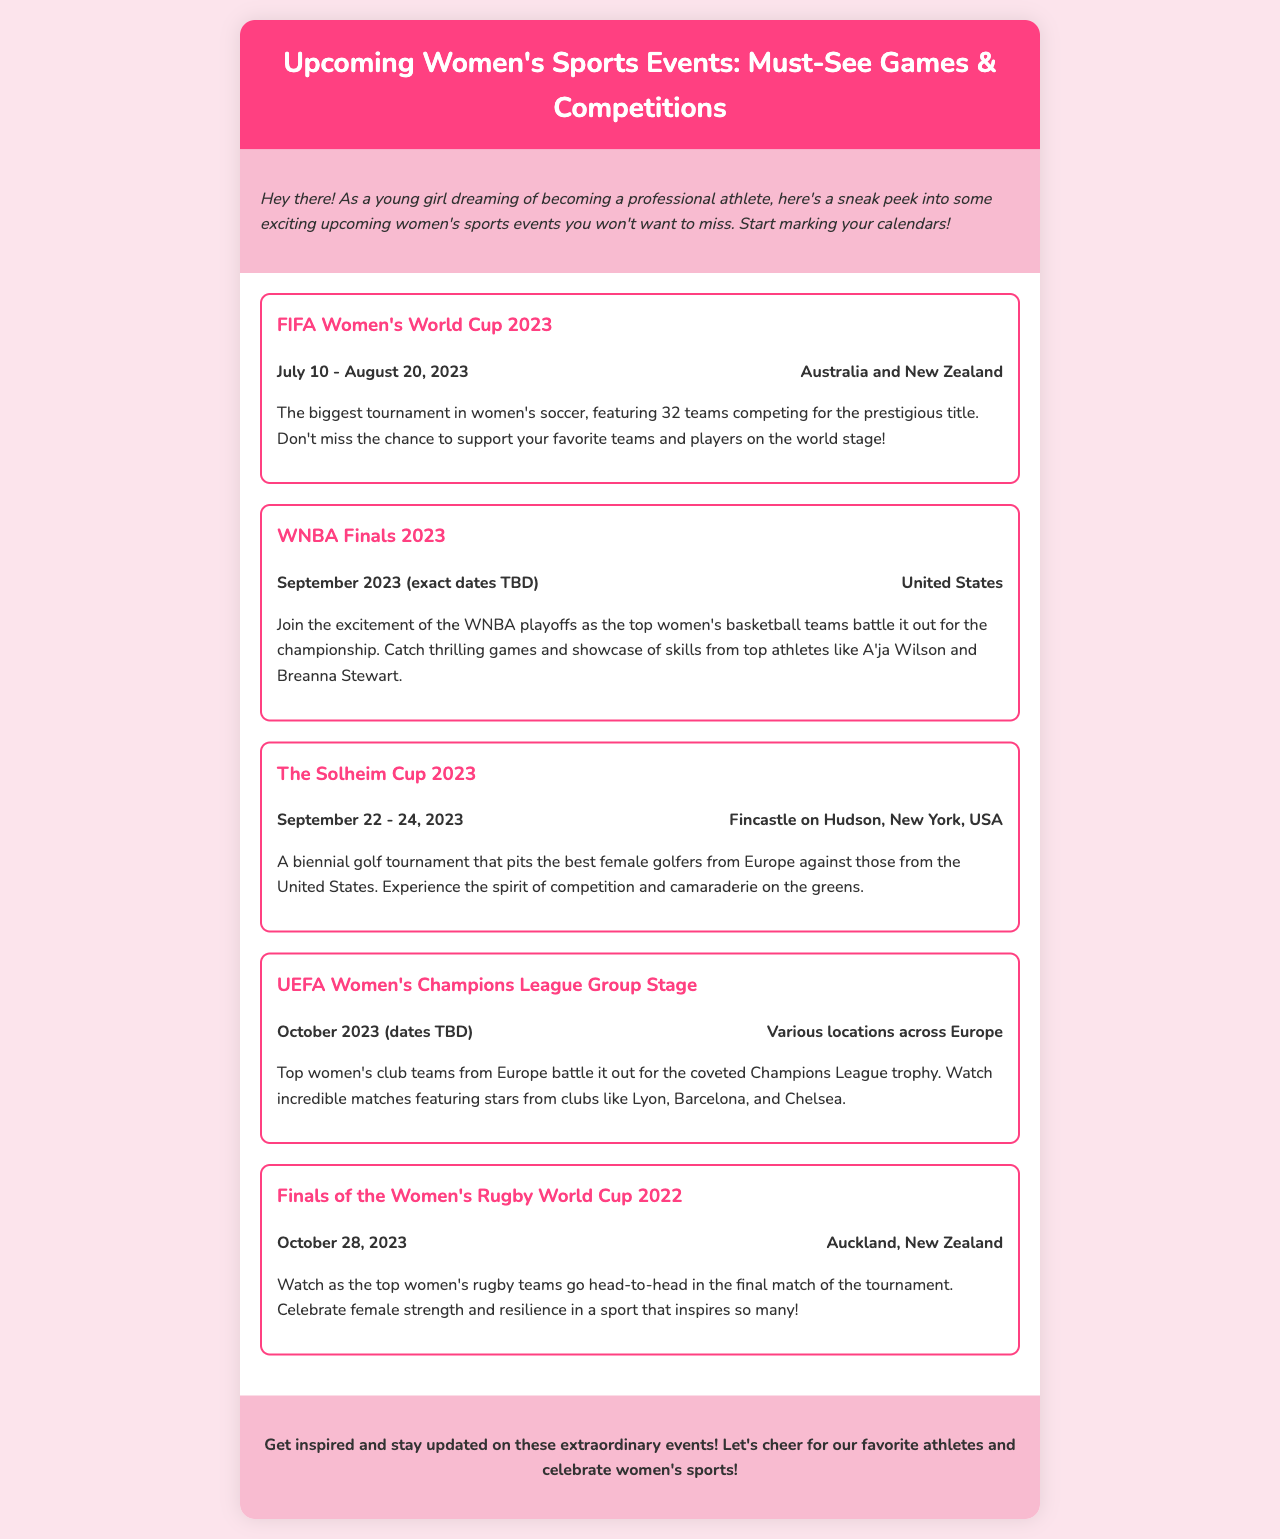What is the title of the newsletter? The title of the newsletter is mentioned at the header section.
Answer: Upcoming Women's Sports Events: Must-See Games & Competitions When does the FIFA Women's World Cup 2023 take place? The dates for the FIFA Women’s World Cup are listed under the event details.
Answer: July 10 - August 20, 2023 Where is the WNBA Finals 2023 held? The location of the WNBA Finals is stated in the event details.
Answer: United States What is the date range for The Solheim Cup 2023? The date range for The Solheim Cup is specified in the event details.
Answer: September 22 - 24, 2023 Which country will host the Finals of the Women's Rugby World Cup 2022? The location of the finals is provided in the event details.
Answer: Auckland, New Zealand How many teams compete in the FIFA Women's World Cup 2023? The number of teams participating in the tournament is mentioned in the event description.
Answer: 32 teams Which sport features the event titled "The Solheim Cup 2023"? The sport associated with The Solheim Cup is identified in the description.
Answer: Golf What is the significance of the UEFA Women's Champions League? The importance of the tournament is implied in the description of the event.
Answer: Coveted Champions League trophy What kind of events does this newsletter highlight? The newsletter focuses on events specific to a particular category of athletics.
Answer: Women's sports events 